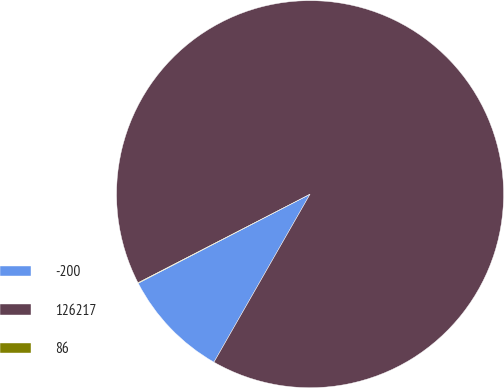Convert chart to OTSL. <chart><loc_0><loc_0><loc_500><loc_500><pie_chart><fcel>-200<fcel>126217<fcel>86<nl><fcel>9.12%<fcel>90.84%<fcel>0.04%<nl></chart> 